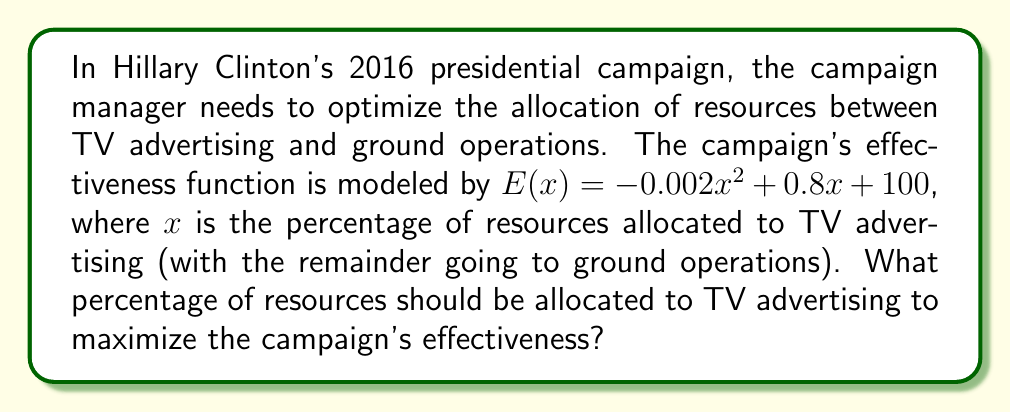Solve this math problem. To find the optimal allocation of resources, we need to find the maximum of the effectiveness function $E(x)$. This can be done by finding the critical point where the derivative of $E(x)$ equals zero.

Step 1: Find the derivative of $E(x)$
$$E'(x) = -0.004x + 0.8$$

Step 2: Set the derivative equal to zero and solve for x
$$-0.004x + 0.8 = 0$$
$$-0.004x = -0.8$$
$$x = 200$$

Step 3: Verify that this critical point is a maximum
The second derivative of $E(x)$ is:
$$E''(x) = -0.004$$
Since $E''(x)$ is negative, the critical point is a maximum.

Step 4: Interpret the result
The value $x = 200$ represents the percentage of resources that should be allocated to TV advertising. However, since percentages cannot exceed 100%, we need to constrain our answer to the valid range of 0-100%.

Step 5: Check the endpoints of the valid range
$E(0) = 100$
$E(100) = 180$

The maximum effectiveness within the valid range occurs at $x = 100$.
Answer: 100% 